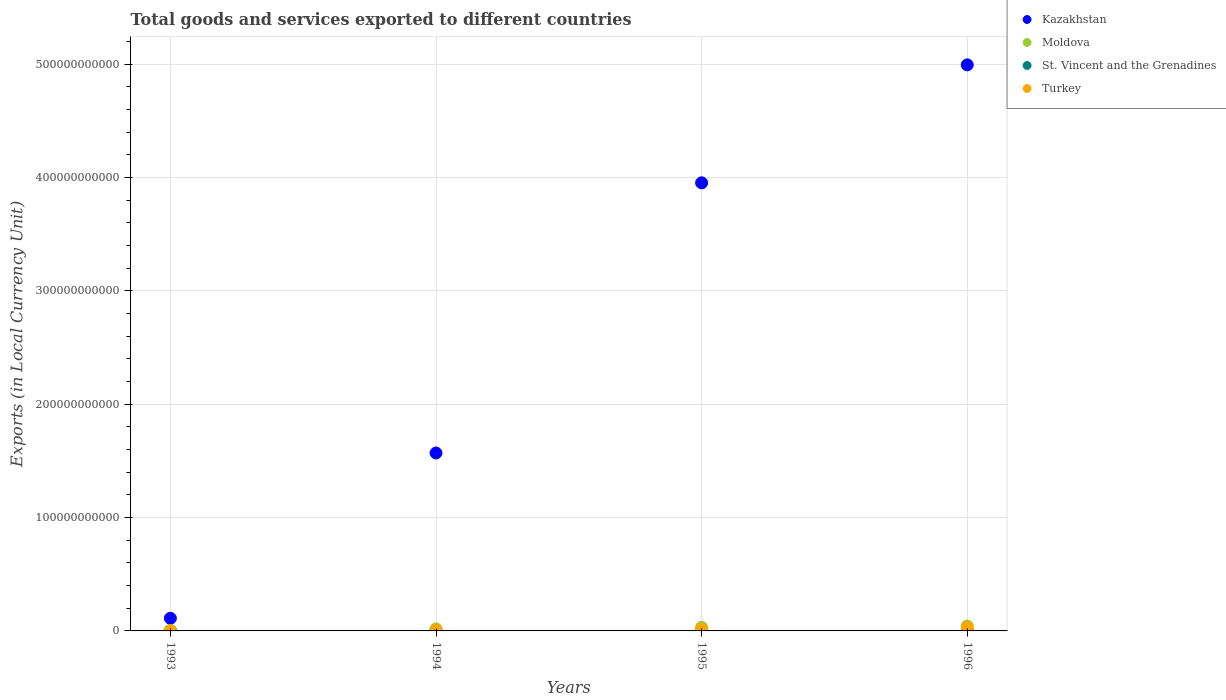What is the Amount of goods and services exports in St. Vincent and the Grenadines in 1996?
Offer a very short reply. 4.03e+08. Across all years, what is the maximum Amount of goods and services exports in Moldova?
Make the answer very short. 4.31e+09. Across all years, what is the minimum Amount of goods and services exports in St. Vincent and the Grenadines?
Keep it short and to the point. 3.03e+08. In which year was the Amount of goods and services exports in St. Vincent and the Grenadines maximum?
Offer a very short reply. 1996. What is the total Amount of goods and services exports in Moldova in the graph?
Make the answer very short. 9.70e+09. What is the difference between the Amount of goods and services exports in Kazakhstan in 1994 and that in 1995?
Provide a short and direct response. -2.38e+11. What is the difference between the Amount of goods and services exports in Kazakhstan in 1994 and the Amount of goods and services exports in St. Vincent and the Grenadines in 1996?
Make the answer very short. 1.57e+11. What is the average Amount of goods and services exports in Moldova per year?
Offer a terse response. 2.43e+09. In the year 1996, what is the difference between the Amount of goods and services exports in Moldova and Amount of goods and services exports in St. Vincent and the Grenadines?
Make the answer very short. 3.91e+09. What is the ratio of the Amount of goods and services exports in St. Vincent and the Grenadines in 1995 to that in 1996?
Your response must be concise. 0.91. Is the difference between the Amount of goods and services exports in Moldova in 1995 and 1996 greater than the difference between the Amount of goods and services exports in St. Vincent and the Grenadines in 1995 and 1996?
Your answer should be very brief. No. What is the difference between the highest and the second highest Amount of goods and services exports in St. Vincent and the Grenadines?
Offer a very short reply. 3.49e+07. What is the difference between the highest and the lowest Amount of goods and services exports in Kazakhstan?
Your answer should be compact. 4.88e+11. In how many years, is the Amount of goods and services exports in Moldova greater than the average Amount of goods and services exports in Moldova taken over all years?
Make the answer very short. 2. Does the Amount of goods and services exports in Kazakhstan monotonically increase over the years?
Keep it short and to the point. Yes. Is the Amount of goods and services exports in Turkey strictly greater than the Amount of goods and services exports in Kazakhstan over the years?
Ensure brevity in your answer.  No. Is the Amount of goods and services exports in Turkey strictly less than the Amount of goods and services exports in Kazakhstan over the years?
Provide a short and direct response. Yes. How many years are there in the graph?
Provide a succinct answer. 4. What is the difference between two consecutive major ticks on the Y-axis?
Provide a succinct answer. 1.00e+11. Are the values on the major ticks of Y-axis written in scientific E-notation?
Ensure brevity in your answer.  No. Does the graph contain any zero values?
Give a very brief answer. No. How many legend labels are there?
Offer a terse response. 4. What is the title of the graph?
Provide a short and direct response. Total goods and services exported to different countries. What is the label or title of the Y-axis?
Your response must be concise. Exports (in Local Currency Unit). What is the Exports (in Local Currency Unit) in Kazakhstan in 1993?
Your answer should be very brief. 1.12e+1. What is the Exports (in Local Currency Unit) in Moldova in 1993?
Keep it short and to the point. 3.85e+08. What is the Exports (in Local Currency Unit) in St. Vincent and the Grenadines in 1993?
Your response must be concise. 3.23e+08. What is the Exports (in Local Currency Unit) in Turkey in 1993?
Make the answer very short. 2.71e+08. What is the Exports (in Local Currency Unit) of Kazakhstan in 1994?
Provide a succinct answer. 1.57e+11. What is the Exports (in Local Currency Unit) of Moldova in 1994?
Give a very brief answer. 1.81e+09. What is the Exports (in Local Currency Unit) of St. Vincent and the Grenadines in 1994?
Keep it short and to the point. 3.03e+08. What is the Exports (in Local Currency Unit) in Turkey in 1994?
Your answer should be very brief. 8.26e+08. What is the Exports (in Local Currency Unit) of Kazakhstan in 1995?
Your response must be concise. 3.95e+11. What is the Exports (in Local Currency Unit) of Moldova in 1995?
Offer a terse response. 3.20e+09. What is the Exports (in Local Currency Unit) of St. Vincent and the Grenadines in 1995?
Provide a short and direct response. 3.68e+08. What is the Exports (in Local Currency Unit) in Turkey in 1995?
Keep it short and to the point. 1.54e+09. What is the Exports (in Local Currency Unit) of Kazakhstan in 1996?
Your answer should be very brief. 4.99e+11. What is the Exports (in Local Currency Unit) in Moldova in 1996?
Offer a terse response. 4.31e+09. What is the Exports (in Local Currency Unit) of St. Vincent and the Grenadines in 1996?
Offer a very short reply. 4.03e+08. What is the Exports (in Local Currency Unit) of Turkey in 1996?
Your answer should be compact. 3.18e+09. Across all years, what is the maximum Exports (in Local Currency Unit) in Kazakhstan?
Keep it short and to the point. 4.99e+11. Across all years, what is the maximum Exports (in Local Currency Unit) in Moldova?
Make the answer very short. 4.31e+09. Across all years, what is the maximum Exports (in Local Currency Unit) in St. Vincent and the Grenadines?
Provide a succinct answer. 4.03e+08. Across all years, what is the maximum Exports (in Local Currency Unit) in Turkey?
Give a very brief answer. 3.18e+09. Across all years, what is the minimum Exports (in Local Currency Unit) in Kazakhstan?
Offer a very short reply. 1.12e+1. Across all years, what is the minimum Exports (in Local Currency Unit) of Moldova?
Give a very brief answer. 3.85e+08. Across all years, what is the minimum Exports (in Local Currency Unit) in St. Vincent and the Grenadines?
Make the answer very short. 3.03e+08. Across all years, what is the minimum Exports (in Local Currency Unit) in Turkey?
Provide a short and direct response. 2.71e+08. What is the total Exports (in Local Currency Unit) in Kazakhstan in the graph?
Keep it short and to the point. 1.06e+12. What is the total Exports (in Local Currency Unit) in Moldova in the graph?
Offer a terse response. 9.70e+09. What is the total Exports (in Local Currency Unit) of St. Vincent and the Grenadines in the graph?
Your answer should be very brief. 1.40e+09. What is the total Exports (in Local Currency Unit) of Turkey in the graph?
Provide a succinct answer. 5.82e+09. What is the difference between the Exports (in Local Currency Unit) in Kazakhstan in 1993 and that in 1994?
Your response must be concise. -1.46e+11. What is the difference between the Exports (in Local Currency Unit) in Moldova in 1993 and that in 1994?
Give a very brief answer. -1.43e+09. What is the difference between the Exports (in Local Currency Unit) of St. Vincent and the Grenadines in 1993 and that in 1994?
Make the answer very short. 1.95e+07. What is the difference between the Exports (in Local Currency Unit) in Turkey in 1993 and that in 1994?
Provide a succinct answer. -5.55e+08. What is the difference between the Exports (in Local Currency Unit) of Kazakhstan in 1993 and that in 1995?
Your response must be concise. -3.84e+11. What is the difference between the Exports (in Local Currency Unit) in Moldova in 1993 and that in 1995?
Your answer should be compact. -2.81e+09. What is the difference between the Exports (in Local Currency Unit) of St. Vincent and the Grenadines in 1993 and that in 1995?
Your answer should be very brief. -4.54e+07. What is the difference between the Exports (in Local Currency Unit) in Turkey in 1993 and that in 1995?
Your answer should be compact. -1.27e+09. What is the difference between the Exports (in Local Currency Unit) of Kazakhstan in 1993 and that in 1996?
Make the answer very short. -4.88e+11. What is the difference between the Exports (in Local Currency Unit) in Moldova in 1993 and that in 1996?
Ensure brevity in your answer.  -3.92e+09. What is the difference between the Exports (in Local Currency Unit) of St. Vincent and the Grenadines in 1993 and that in 1996?
Keep it short and to the point. -8.03e+07. What is the difference between the Exports (in Local Currency Unit) of Turkey in 1993 and that in 1996?
Provide a succinct answer. -2.91e+09. What is the difference between the Exports (in Local Currency Unit) in Kazakhstan in 1994 and that in 1995?
Your answer should be very brief. -2.38e+11. What is the difference between the Exports (in Local Currency Unit) of Moldova in 1994 and that in 1995?
Give a very brief answer. -1.39e+09. What is the difference between the Exports (in Local Currency Unit) of St. Vincent and the Grenadines in 1994 and that in 1995?
Your response must be concise. -6.50e+07. What is the difference between the Exports (in Local Currency Unit) in Turkey in 1994 and that in 1995?
Your answer should be very brief. -7.18e+08. What is the difference between the Exports (in Local Currency Unit) in Kazakhstan in 1994 and that in 1996?
Ensure brevity in your answer.  -3.42e+11. What is the difference between the Exports (in Local Currency Unit) of Moldova in 1994 and that in 1996?
Give a very brief answer. -2.50e+09. What is the difference between the Exports (in Local Currency Unit) in St. Vincent and the Grenadines in 1994 and that in 1996?
Make the answer very short. -9.98e+07. What is the difference between the Exports (in Local Currency Unit) of Turkey in 1994 and that in 1996?
Make the answer very short. -2.36e+09. What is the difference between the Exports (in Local Currency Unit) of Kazakhstan in 1995 and that in 1996?
Keep it short and to the point. -1.04e+11. What is the difference between the Exports (in Local Currency Unit) in Moldova in 1995 and that in 1996?
Ensure brevity in your answer.  -1.11e+09. What is the difference between the Exports (in Local Currency Unit) in St. Vincent and the Grenadines in 1995 and that in 1996?
Give a very brief answer. -3.49e+07. What is the difference between the Exports (in Local Currency Unit) in Turkey in 1995 and that in 1996?
Offer a terse response. -1.64e+09. What is the difference between the Exports (in Local Currency Unit) in Kazakhstan in 1993 and the Exports (in Local Currency Unit) in Moldova in 1994?
Provide a succinct answer. 9.34e+09. What is the difference between the Exports (in Local Currency Unit) in Kazakhstan in 1993 and the Exports (in Local Currency Unit) in St. Vincent and the Grenadines in 1994?
Make the answer very short. 1.08e+1. What is the difference between the Exports (in Local Currency Unit) of Kazakhstan in 1993 and the Exports (in Local Currency Unit) of Turkey in 1994?
Provide a succinct answer. 1.03e+1. What is the difference between the Exports (in Local Currency Unit) of Moldova in 1993 and the Exports (in Local Currency Unit) of St. Vincent and the Grenadines in 1994?
Keep it short and to the point. 8.16e+07. What is the difference between the Exports (in Local Currency Unit) in Moldova in 1993 and the Exports (in Local Currency Unit) in Turkey in 1994?
Offer a very short reply. -4.42e+08. What is the difference between the Exports (in Local Currency Unit) of St. Vincent and the Grenadines in 1993 and the Exports (in Local Currency Unit) of Turkey in 1994?
Make the answer very short. -5.04e+08. What is the difference between the Exports (in Local Currency Unit) in Kazakhstan in 1993 and the Exports (in Local Currency Unit) in Moldova in 1995?
Offer a very short reply. 7.95e+09. What is the difference between the Exports (in Local Currency Unit) of Kazakhstan in 1993 and the Exports (in Local Currency Unit) of St. Vincent and the Grenadines in 1995?
Offer a terse response. 1.08e+1. What is the difference between the Exports (in Local Currency Unit) of Kazakhstan in 1993 and the Exports (in Local Currency Unit) of Turkey in 1995?
Your response must be concise. 9.61e+09. What is the difference between the Exports (in Local Currency Unit) of Moldova in 1993 and the Exports (in Local Currency Unit) of St. Vincent and the Grenadines in 1995?
Make the answer very short. 1.66e+07. What is the difference between the Exports (in Local Currency Unit) of Moldova in 1993 and the Exports (in Local Currency Unit) of Turkey in 1995?
Provide a succinct answer. -1.16e+09. What is the difference between the Exports (in Local Currency Unit) in St. Vincent and the Grenadines in 1993 and the Exports (in Local Currency Unit) in Turkey in 1995?
Provide a succinct answer. -1.22e+09. What is the difference between the Exports (in Local Currency Unit) of Kazakhstan in 1993 and the Exports (in Local Currency Unit) of Moldova in 1996?
Provide a succinct answer. 6.84e+09. What is the difference between the Exports (in Local Currency Unit) of Kazakhstan in 1993 and the Exports (in Local Currency Unit) of St. Vincent and the Grenadines in 1996?
Provide a succinct answer. 1.07e+1. What is the difference between the Exports (in Local Currency Unit) in Kazakhstan in 1993 and the Exports (in Local Currency Unit) in Turkey in 1996?
Offer a terse response. 7.97e+09. What is the difference between the Exports (in Local Currency Unit) of Moldova in 1993 and the Exports (in Local Currency Unit) of St. Vincent and the Grenadines in 1996?
Provide a succinct answer. -1.83e+07. What is the difference between the Exports (in Local Currency Unit) of Moldova in 1993 and the Exports (in Local Currency Unit) of Turkey in 1996?
Offer a very short reply. -2.80e+09. What is the difference between the Exports (in Local Currency Unit) in St. Vincent and the Grenadines in 1993 and the Exports (in Local Currency Unit) in Turkey in 1996?
Offer a terse response. -2.86e+09. What is the difference between the Exports (in Local Currency Unit) in Kazakhstan in 1994 and the Exports (in Local Currency Unit) in Moldova in 1995?
Provide a succinct answer. 1.54e+11. What is the difference between the Exports (in Local Currency Unit) of Kazakhstan in 1994 and the Exports (in Local Currency Unit) of St. Vincent and the Grenadines in 1995?
Provide a short and direct response. 1.57e+11. What is the difference between the Exports (in Local Currency Unit) in Kazakhstan in 1994 and the Exports (in Local Currency Unit) in Turkey in 1995?
Your answer should be very brief. 1.55e+11. What is the difference between the Exports (in Local Currency Unit) in Moldova in 1994 and the Exports (in Local Currency Unit) in St. Vincent and the Grenadines in 1995?
Your response must be concise. 1.44e+09. What is the difference between the Exports (in Local Currency Unit) of Moldova in 1994 and the Exports (in Local Currency Unit) of Turkey in 1995?
Provide a succinct answer. 2.67e+08. What is the difference between the Exports (in Local Currency Unit) in St. Vincent and the Grenadines in 1994 and the Exports (in Local Currency Unit) in Turkey in 1995?
Make the answer very short. -1.24e+09. What is the difference between the Exports (in Local Currency Unit) in Kazakhstan in 1994 and the Exports (in Local Currency Unit) in Moldova in 1996?
Provide a succinct answer. 1.53e+11. What is the difference between the Exports (in Local Currency Unit) of Kazakhstan in 1994 and the Exports (in Local Currency Unit) of St. Vincent and the Grenadines in 1996?
Your answer should be very brief. 1.57e+11. What is the difference between the Exports (in Local Currency Unit) of Kazakhstan in 1994 and the Exports (in Local Currency Unit) of Turkey in 1996?
Your answer should be compact. 1.54e+11. What is the difference between the Exports (in Local Currency Unit) in Moldova in 1994 and the Exports (in Local Currency Unit) in St. Vincent and the Grenadines in 1996?
Your answer should be very brief. 1.41e+09. What is the difference between the Exports (in Local Currency Unit) of Moldova in 1994 and the Exports (in Local Currency Unit) of Turkey in 1996?
Give a very brief answer. -1.37e+09. What is the difference between the Exports (in Local Currency Unit) in St. Vincent and the Grenadines in 1994 and the Exports (in Local Currency Unit) in Turkey in 1996?
Your answer should be very brief. -2.88e+09. What is the difference between the Exports (in Local Currency Unit) in Kazakhstan in 1995 and the Exports (in Local Currency Unit) in Moldova in 1996?
Your answer should be compact. 3.91e+11. What is the difference between the Exports (in Local Currency Unit) in Kazakhstan in 1995 and the Exports (in Local Currency Unit) in St. Vincent and the Grenadines in 1996?
Give a very brief answer. 3.95e+11. What is the difference between the Exports (in Local Currency Unit) of Kazakhstan in 1995 and the Exports (in Local Currency Unit) of Turkey in 1996?
Provide a succinct answer. 3.92e+11. What is the difference between the Exports (in Local Currency Unit) of Moldova in 1995 and the Exports (in Local Currency Unit) of St. Vincent and the Grenadines in 1996?
Provide a short and direct response. 2.79e+09. What is the difference between the Exports (in Local Currency Unit) of Moldova in 1995 and the Exports (in Local Currency Unit) of Turkey in 1996?
Keep it short and to the point. 1.52e+07. What is the difference between the Exports (in Local Currency Unit) in St. Vincent and the Grenadines in 1995 and the Exports (in Local Currency Unit) in Turkey in 1996?
Keep it short and to the point. -2.81e+09. What is the average Exports (in Local Currency Unit) in Kazakhstan per year?
Provide a succinct answer. 2.66e+11. What is the average Exports (in Local Currency Unit) of Moldova per year?
Keep it short and to the point. 2.43e+09. What is the average Exports (in Local Currency Unit) of St. Vincent and the Grenadines per year?
Offer a very short reply. 3.49e+08. What is the average Exports (in Local Currency Unit) of Turkey per year?
Offer a very short reply. 1.46e+09. In the year 1993, what is the difference between the Exports (in Local Currency Unit) in Kazakhstan and Exports (in Local Currency Unit) in Moldova?
Provide a succinct answer. 1.08e+1. In the year 1993, what is the difference between the Exports (in Local Currency Unit) in Kazakhstan and Exports (in Local Currency Unit) in St. Vincent and the Grenadines?
Your answer should be compact. 1.08e+1. In the year 1993, what is the difference between the Exports (in Local Currency Unit) in Kazakhstan and Exports (in Local Currency Unit) in Turkey?
Ensure brevity in your answer.  1.09e+1. In the year 1993, what is the difference between the Exports (in Local Currency Unit) of Moldova and Exports (in Local Currency Unit) of St. Vincent and the Grenadines?
Offer a very short reply. 6.21e+07. In the year 1993, what is the difference between the Exports (in Local Currency Unit) in Moldova and Exports (in Local Currency Unit) in Turkey?
Keep it short and to the point. 1.14e+08. In the year 1993, what is the difference between the Exports (in Local Currency Unit) in St. Vincent and the Grenadines and Exports (in Local Currency Unit) in Turkey?
Give a very brief answer. 5.16e+07. In the year 1994, what is the difference between the Exports (in Local Currency Unit) in Kazakhstan and Exports (in Local Currency Unit) in Moldova?
Your answer should be very brief. 1.55e+11. In the year 1994, what is the difference between the Exports (in Local Currency Unit) in Kazakhstan and Exports (in Local Currency Unit) in St. Vincent and the Grenadines?
Give a very brief answer. 1.57e+11. In the year 1994, what is the difference between the Exports (in Local Currency Unit) in Kazakhstan and Exports (in Local Currency Unit) in Turkey?
Your answer should be compact. 1.56e+11. In the year 1994, what is the difference between the Exports (in Local Currency Unit) in Moldova and Exports (in Local Currency Unit) in St. Vincent and the Grenadines?
Give a very brief answer. 1.51e+09. In the year 1994, what is the difference between the Exports (in Local Currency Unit) of Moldova and Exports (in Local Currency Unit) of Turkey?
Offer a terse response. 9.85e+08. In the year 1994, what is the difference between the Exports (in Local Currency Unit) in St. Vincent and the Grenadines and Exports (in Local Currency Unit) in Turkey?
Provide a succinct answer. -5.23e+08. In the year 1995, what is the difference between the Exports (in Local Currency Unit) of Kazakhstan and Exports (in Local Currency Unit) of Moldova?
Your answer should be compact. 3.92e+11. In the year 1995, what is the difference between the Exports (in Local Currency Unit) of Kazakhstan and Exports (in Local Currency Unit) of St. Vincent and the Grenadines?
Offer a very short reply. 3.95e+11. In the year 1995, what is the difference between the Exports (in Local Currency Unit) in Kazakhstan and Exports (in Local Currency Unit) in Turkey?
Provide a succinct answer. 3.94e+11. In the year 1995, what is the difference between the Exports (in Local Currency Unit) of Moldova and Exports (in Local Currency Unit) of St. Vincent and the Grenadines?
Ensure brevity in your answer.  2.83e+09. In the year 1995, what is the difference between the Exports (in Local Currency Unit) of Moldova and Exports (in Local Currency Unit) of Turkey?
Give a very brief answer. 1.65e+09. In the year 1995, what is the difference between the Exports (in Local Currency Unit) of St. Vincent and the Grenadines and Exports (in Local Currency Unit) of Turkey?
Your response must be concise. -1.18e+09. In the year 1996, what is the difference between the Exports (in Local Currency Unit) of Kazakhstan and Exports (in Local Currency Unit) of Moldova?
Offer a very short reply. 4.95e+11. In the year 1996, what is the difference between the Exports (in Local Currency Unit) of Kazakhstan and Exports (in Local Currency Unit) of St. Vincent and the Grenadines?
Give a very brief answer. 4.99e+11. In the year 1996, what is the difference between the Exports (in Local Currency Unit) of Kazakhstan and Exports (in Local Currency Unit) of Turkey?
Make the answer very short. 4.96e+11. In the year 1996, what is the difference between the Exports (in Local Currency Unit) of Moldova and Exports (in Local Currency Unit) of St. Vincent and the Grenadines?
Your answer should be compact. 3.91e+09. In the year 1996, what is the difference between the Exports (in Local Currency Unit) of Moldova and Exports (in Local Currency Unit) of Turkey?
Offer a very short reply. 1.13e+09. In the year 1996, what is the difference between the Exports (in Local Currency Unit) in St. Vincent and the Grenadines and Exports (in Local Currency Unit) in Turkey?
Give a very brief answer. -2.78e+09. What is the ratio of the Exports (in Local Currency Unit) in Kazakhstan in 1993 to that in 1994?
Offer a terse response. 0.07. What is the ratio of the Exports (in Local Currency Unit) in Moldova in 1993 to that in 1994?
Your answer should be very brief. 0.21. What is the ratio of the Exports (in Local Currency Unit) in St. Vincent and the Grenadines in 1993 to that in 1994?
Provide a succinct answer. 1.06. What is the ratio of the Exports (in Local Currency Unit) of Turkey in 1993 to that in 1994?
Your answer should be very brief. 0.33. What is the ratio of the Exports (in Local Currency Unit) in Kazakhstan in 1993 to that in 1995?
Keep it short and to the point. 0.03. What is the ratio of the Exports (in Local Currency Unit) of Moldova in 1993 to that in 1995?
Give a very brief answer. 0.12. What is the ratio of the Exports (in Local Currency Unit) in St. Vincent and the Grenadines in 1993 to that in 1995?
Offer a very short reply. 0.88. What is the ratio of the Exports (in Local Currency Unit) in Turkey in 1993 to that in 1995?
Your answer should be very brief. 0.18. What is the ratio of the Exports (in Local Currency Unit) in Kazakhstan in 1993 to that in 1996?
Provide a succinct answer. 0.02. What is the ratio of the Exports (in Local Currency Unit) in Moldova in 1993 to that in 1996?
Your answer should be very brief. 0.09. What is the ratio of the Exports (in Local Currency Unit) in St. Vincent and the Grenadines in 1993 to that in 1996?
Your response must be concise. 0.8. What is the ratio of the Exports (in Local Currency Unit) in Turkey in 1993 to that in 1996?
Offer a very short reply. 0.09. What is the ratio of the Exports (in Local Currency Unit) in Kazakhstan in 1994 to that in 1995?
Make the answer very short. 0.4. What is the ratio of the Exports (in Local Currency Unit) in Moldova in 1994 to that in 1995?
Your answer should be compact. 0.57. What is the ratio of the Exports (in Local Currency Unit) of St. Vincent and the Grenadines in 1994 to that in 1995?
Your answer should be compact. 0.82. What is the ratio of the Exports (in Local Currency Unit) in Turkey in 1994 to that in 1995?
Ensure brevity in your answer.  0.54. What is the ratio of the Exports (in Local Currency Unit) of Kazakhstan in 1994 to that in 1996?
Give a very brief answer. 0.31. What is the ratio of the Exports (in Local Currency Unit) in Moldova in 1994 to that in 1996?
Offer a very short reply. 0.42. What is the ratio of the Exports (in Local Currency Unit) of St. Vincent and the Grenadines in 1994 to that in 1996?
Your answer should be very brief. 0.75. What is the ratio of the Exports (in Local Currency Unit) of Turkey in 1994 to that in 1996?
Keep it short and to the point. 0.26. What is the ratio of the Exports (in Local Currency Unit) of Kazakhstan in 1995 to that in 1996?
Give a very brief answer. 0.79. What is the ratio of the Exports (in Local Currency Unit) in Moldova in 1995 to that in 1996?
Your answer should be compact. 0.74. What is the ratio of the Exports (in Local Currency Unit) in St. Vincent and the Grenadines in 1995 to that in 1996?
Ensure brevity in your answer.  0.91. What is the ratio of the Exports (in Local Currency Unit) of Turkey in 1995 to that in 1996?
Your answer should be very brief. 0.49. What is the difference between the highest and the second highest Exports (in Local Currency Unit) in Kazakhstan?
Keep it short and to the point. 1.04e+11. What is the difference between the highest and the second highest Exports (in Local Currency Unit) of Moldova?
Provide a short and direct response. 1.11e+09. What is the difference between the highest and the second highest Exports (in Local Currency Unit) of St. Vincent and the Grenadines?
Keep it short and to the point. 3.49e+07. What is the difference between the highest and the second highest Exports (in Local Currency Unit) of Turkey?
Keep it short and to the point. 1.64e+09. What is the difference between the highest and the lowest Exports (in Local Currency Unit) of Kazakhstan?
Your response must be concise. 4.88e+11. What is the difference between the highest and the lowest Exports (in Local Currency Unit) in Moldova?
Ensure brevity in your answer.  3.92e+09. What is the difference between the highest and the lowest Exports (in Local Currency Unit) of St. Vincent and the Grenadines?
Keep it short and to the point. 9.98e+07. What is the difference between the highest and the lowest Exports (in Local Currency Unit) of Turkey?
Offer a terse response. 2.91e+09. 